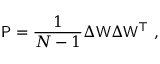<formula> <loc_0><loc_0><loc_500><loc_500>P = \frac { 1 } { N - 1 } \Delta W \Delta W ^ { \top } ,</formula> 